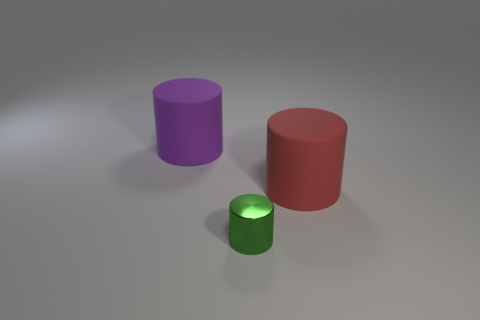The green object is what shape?
Your response must be concise. Cylinder. Is the red object made of the same material as the big purple thing that is left of the green metallic cylinder?
Make the answer very short. Yes. How many things are either large brown cylinders or cylinders?
Offer a terse response. 3. Is there a small green metallic cube?
Your response must be concise. No. What is the shape of the large red object that is in front of the rubber object on the left side of the green metallic thing?
Offer a terse response. Cylinder. What number of things are cylinders to the left of the metallic thing or cylinders that are on the left side of the red cylinder?
Provide a succinct answer. 2. There is a red cylinder that is the same size as the purple matte cylinder; what material is it?
Your response must be concise. Rubber. The small cylinder is what color?
Your answer should be compact. Green. There is a cylinder that is behind the metal object and on the left side of the red thing; what is its material?
Ensure brevity in your answer.  Rubber. Is there a large rubber thing that is behind the large thing that is in front of the large rubber cylinder that is on the left side of the tiny metallic cylinder?
Your answer should be compact. Yes. 